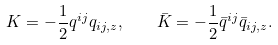<formula> <loc_0><loc_0><loc_500><loc_500>K = - \frac { 1 } { 2 } q ^ { i j } q _ { i j , z } , \quad \bar { K } = - \frac { 1 } { 2 } \bar { q } ^ { i j } \bar { q } _ { i j , z } .</formula> 